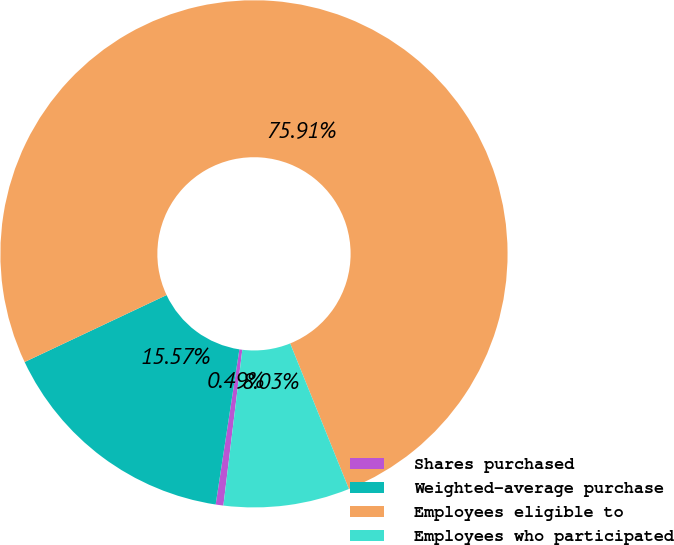Convert chart to OTSL. <chart><loc_0><loc_0><loc_500><loc_500><pie_chart><fcel>Shares purchased<fcel>Weighted-average purchase<fcel>Employees eligible to<fcel>Employees who participated<nl><fcel>0.49%<fcel>15.57%<fcel>75.9%<fcel>8.03%<nl></chart> 